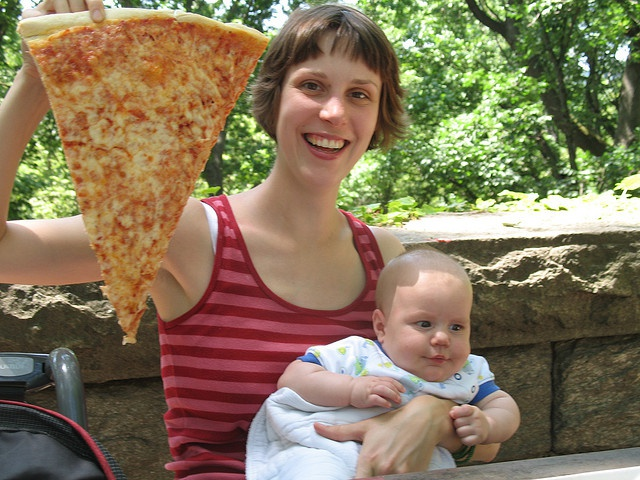Describe the objects in this image and their specific colors. I can see people in lightblue, brown, maroon, and tan tones, pizza in lightblue, brown, and tan tones, and people in lightblue, lavender, gray, darkgray, and tan tones in this image. 